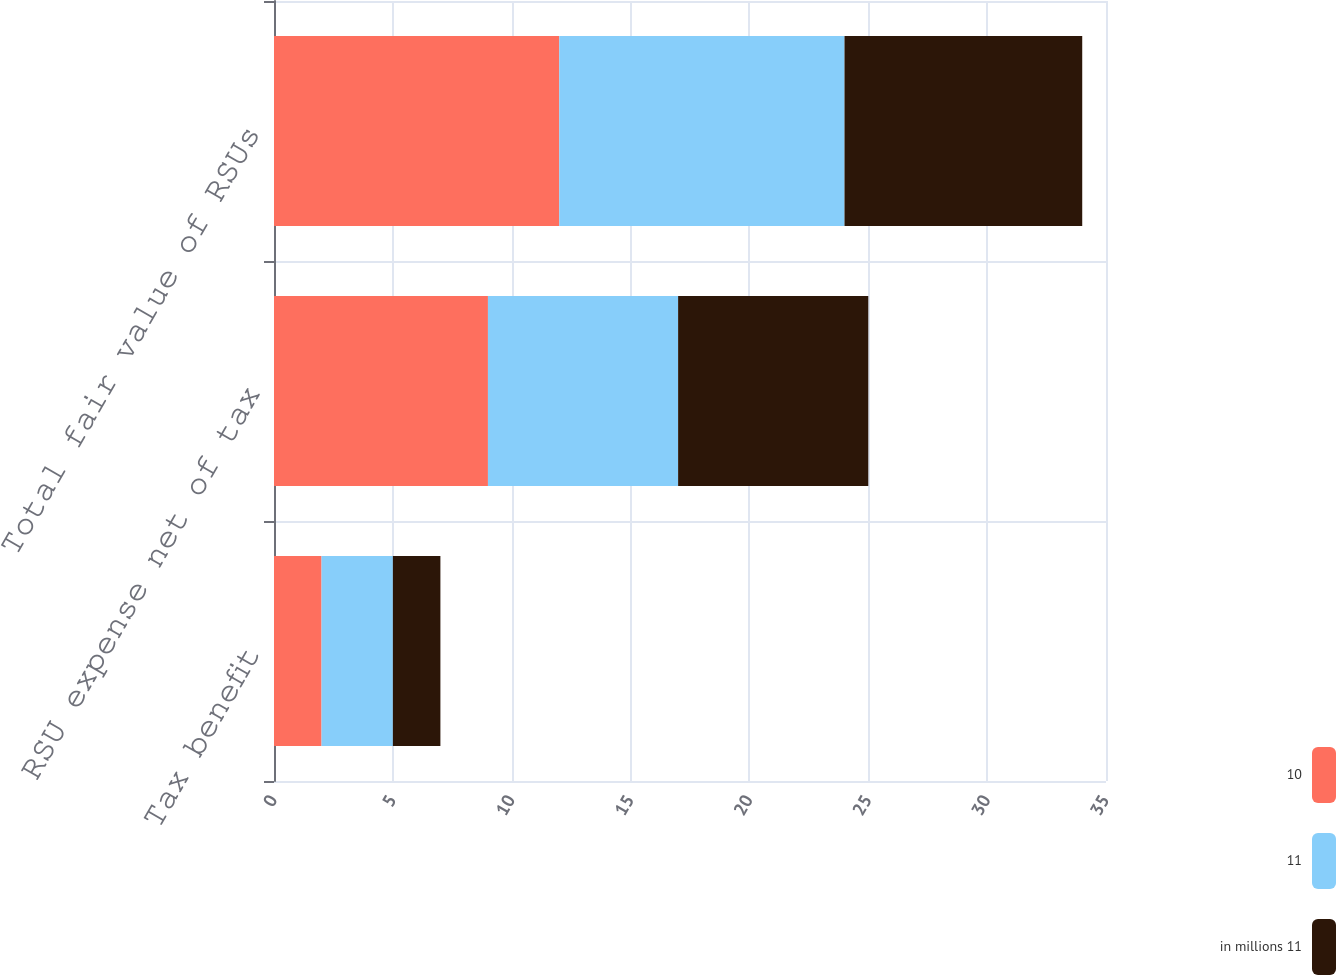Convert chart to OTSL. <chart><loc_0><loc_0><loc_500><loc_500><stacked_bar_chart><ecel><fcel>Tax benefit<fcel>RSU expense net of tax<fcel>Total fair value of RSUs<nl><fcel>10<fcel>2<fcel>9<fcel>12<nl><fcel>11<fcel>3<fcel>8<fcel>12<nl><fcel>in millions 11<fcel>2<fcel>8<fcel>10<nl></chart> 